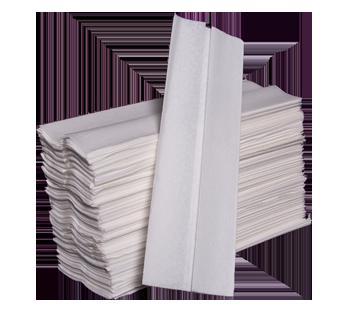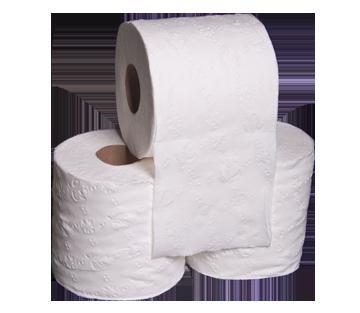The first image is the image on the left, the second image is the image on the right. For the images displayed, is the sentence "Both images show white paper towels on rolls." factually correct? Answer yes or no. No. The first image is the image on the left, the second image is the image on the right. Evaluate the accuracy of this statement regarding the images: "An image shows exactly one roll standing next to one roll on its side.". Is it true? Answer yes or no. No. 